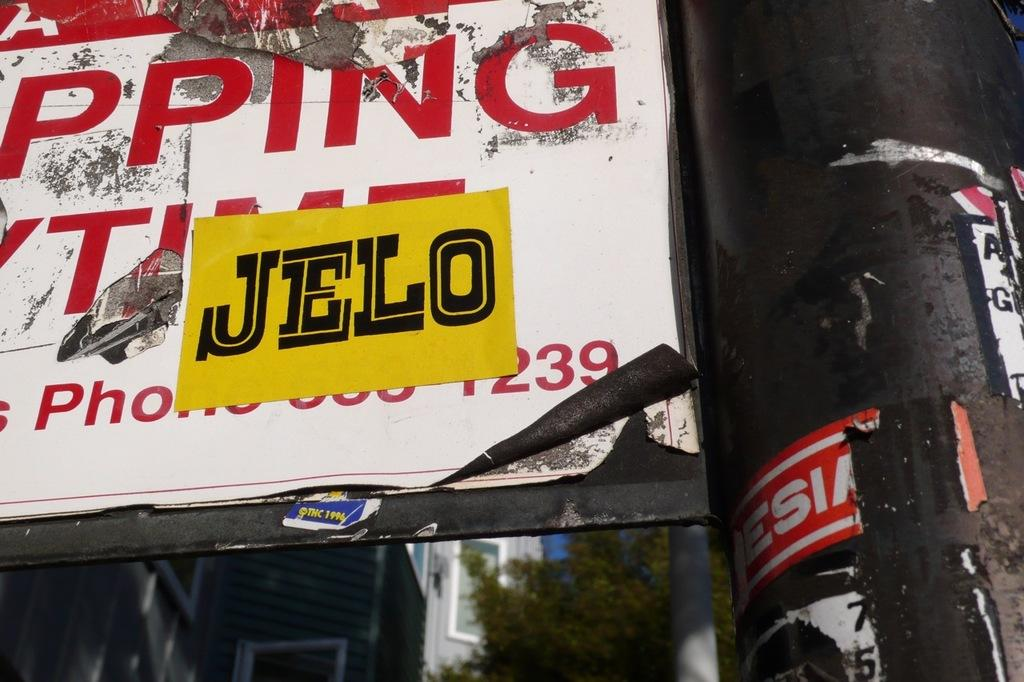What objects are present on the boards in the image? There are stickers pasted on the boards in the image. What can be seen at the bottom of the image? There are buildings and a tree at the bottom of the image. What type of song is being played by the organization in the image? There is no organization or song present in the image; it features boards with stickers and buildings with a tree. 